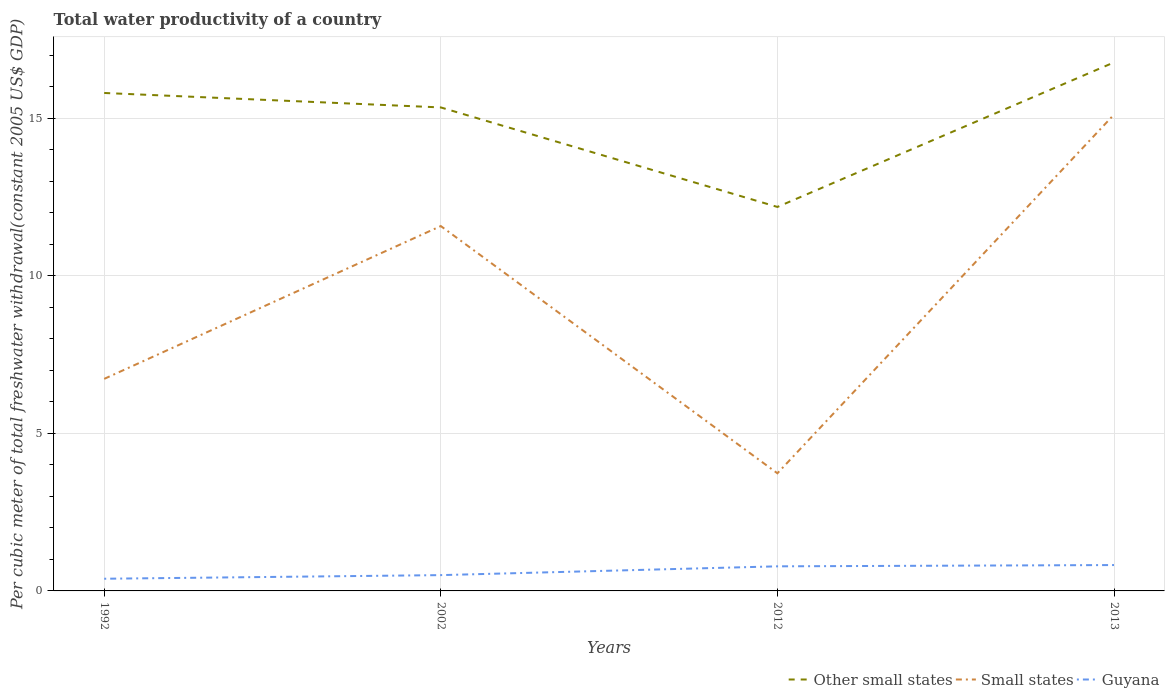Does the line corresponding to Small states intersect with the line corresponding to Guyana?
Keep it short and to the point. No. Across all years, what is the maximum total water productivity in Other small states?
Offer a terse response. 12.19. In which year was the total water productivity in Guyana maximum?
Provide a succinct answer. 1992. What is the total total water productivity in Guyana in the graph?
Ensure brevity in your answer.  -0.43. What is the difference between the highest and the second highest total water productivity in Other small states?
Your answer should be compact. 4.59. Is the total water productivity in Other small states strictly greater than the total water productivity in Guyana over the years?
Give a very brief answer. No. How many years are there in the graph?
Ensure brevity in your answer.  4. Does the graph contain grids?
Your answer should be compact. Yes. How many legend labels are there?
Ensure brevity in your answer.  3. How are the legend labels stacked?
Provide a succinct answer. Horizontal. What is the title of the graph?
Provide a short and direct response. Total water productivity of a country. Does "Macao" appear as one of the legend labels in the graph?
Your answer should be compact. No. What is the label or title of the Y-axis?
Your answer should be compact. Per cubic meter of total freshwater withdrawal(constant 2005 US$ GDP). What is the Per cubic meter of total freshwater withdrawal(constant 2005 US$ GDP) of Other small states in 1992?
Give a very brief answer. 15.81. What is the Per cubic meter of total freshwater withdrawal(constant 2005 US$ GDP) in Small states in 1992?
Ensure brevity in your answer.  6.73. What is the Per cubic meter of total freshwater withdrawal(constant 2005 US$ GDP) in Guyana in 1992?
Offer a terse response. 0.39. What is the Per cubic meter of total freshwater withdrawal(constant 2005 US$ GDP) in Other small states in 2002?
Provide a short and direct response. 15.35. What is the Per cubic meter of total freshwater withdrawal(constant 2005 US$ GDP) in Small states in 2002?
Provide a succinct answer. 11.58. What is the Per cubic meter of total freshwater withdrawal(constant 2005 US$ GDP) of Guyana in 2002?
Make the answer very short. 0.5. What is the Per cubic meter of total freshwater withdrawal(constant 2005 US$ GDP) of Other small states in 2012?
Ensure brevity in your answer.  12.19. What is the Per cubic meter of total freshwater withdrawal(constant 2005 US$ GDP) of Small states in 2012?
Your answer should be compact. 3.73. What is the Per cubic meter of total freshwater withdrawal(constant 2005 US$ GDP) of Guyana in 2012?
Your response must be concise. 0.78. What is the Per cubic meter of total freshwater withdrawal(constant 2005 US$ GDP) of Other small states in 2013?
Make the answer very short. 16.78. What is the Per cubic meter of total freshwater withdrawal(constant 2005 US$ GDP) of Small states in 2013?
Make the answer very short. 15.12. What is the Per cubic meter of total freshwater withdrawal(constant 2005 US$ GDP) in Guyana in 2013?
Keep it short and to the point. 0.82. Across all years, what is the maximum Per cubic meter of total freshwater withdrawal(constant 2005 US$ GDP) in Other small states?
Your answer should be compact. 16.78. Across all years, what is the maximum Per cubic meter of total freshwater withdrawal(constant 2005 US$ GDP) in Small states?
Offer a terse response. 15.12. Across all years, what is the maximum Per cubic meter of total freshwater withdrawal(constant 2005 US$ GDP) of Guyana?
Give a very brief answer. 0.82. Across all years, what is the minimum Per cubic meter of total freshwater withdrawal(constant 2005 US$ GDP) of Other small states?
Offer a terse response. 12.19. Across all years, what is the minimum Per cubic meter of total freshwater withdrawal(constant 2005 US$ GDP) in Small states?
Provide a short and direct response. 3.73. Across all years, what is the minimum Per cubic meter of total freshwater withdrawal(constant 2005 US$ GDP) of Guyana?
Your answer should be compact. 0.39. What is the total Per cubic meter of total freshwater withdrawal(constant 2005 US$ GDP) in Other small states in the graph?
Give a very brief answer. 60.12. What is the total Per cubic meter of total freshwater withdrawal(constant 2005 US$ GDP) in Small states in the graph?
Offer a terse response. 37.17. What is the total Per cubic meter of total freshwater withdrawal(constant 2005 US$ GDP) in Guyana in the graph?
Provide a succinct answer. 2.49. What is the difference between the Per cubic meter of total freshwater withdrawal(constant 2005 US$ GDP) in Other small states in 1992 and that in 2002?
Ensure brevity in your answer.  0.46. What is the difference between the Per cubic meter of total freshwater withdrawal(constant 2005 US$ GDP) in Small states in 1992 and that in 2002?
Your response must be concise. -4.85. What is the difference between the Per cubic meter of total freshwater withdrawal(constant 2005 US$ GDP) of Guyana in 1992 and that in 2002?
Offer a very short reply. -0.12. What is the difference between the Per cubic meter of total freshwater withdrawal(constant 2005 US$ GDP) of Other small states in 1992 and that in 2012?
Offer a very short reply. 3.62. What is the difference between the Per cubic meter of total freshwater withdrawal(constant 2005 US$ GDP) in Small states in 1992 and that in 2012?
Offer a terse response. 3. What is the difference between the Per cubic meter of total freshwater withdrawal(constant 2005 US$ GDP) of Guyana in 1992 and that in 2012?
Offer a terse response. -0.39. What is the difference between the Per cubic meter of total freshwater withdrawal(constant 2005 US$ GDP) in Other small states in 1992 and that in 2013?
Keep it short and to the point. -0.97. What is the difference between the Per cubic meter of total freshwater withdrawal(constant 2005 US$ GDP) of Small states in 1992 and that in 2013?
Offer a very short reply. -8.39. What is the difference between the Per cubic meter of total freshwater withdrawal(constant 2005 US$ GDP) in Guyana in 1992 and that in 2013?
Give a very brief answer. -0.43. What is the difference between the Per cubic meter of total freshwater withdrawal(constant 2005 US$ GDP) of Other small states in 2002 and that in 2012?
Make the answer very short. 3.16. What is the difference between the Per cubic meter of total freshwater withdrawal(constant 2005 US$ GDP) of Small states in 2002 and that in 2012?
Provide a succinct answer. 7.85. What is the difference between the Per cubic meter of total freshwater withdrawal(constant 2005 US$ GDP) of Guyana in 2002 and that in 2012?
Offer a very short reply. -0.28. What is the difference between the Per cubic meter of total freshwater withdrawal(constant 2005 US$ GDP) in Other small states in 2002 and that in 2013?
Your answer should be very brief. -1.43. What is the difference between the Per cubic meter of total freshwater withdrawal(constant 2005 US$ GDP) in Small states in 2002 and that in 2013?
Offer a terse response. -3.54. What is the difference between the Per cubic meter of total freshwater withdrawal(constant 2005 US$ GDP) of Guyana in 2002 and that in 2013?
Give a very brief answer. -0.32. What is the difference between the Per cubic meter of total freshwater withdrawal(constant 2005 US$ GDP) of Other small states in 2012 and that in 2013?
Ensure brevity in your answer.  -4.59. What is the difference between the Per cubic meter of total freshwater withdrawal(constant 2005 US$ GDP) in Small states in 2012 and that in 2013?
Your response must be concise. -11.39. What is the difference between the Per cubic meter of total freshwater withdrawal(constant 2005 US$ GDP) in Guyana in 2012 and that in 2013?
Offer a very short reply. -0.04. What is the difference between the Per cubic meter of total freshwater withdrawal(constant 2005 US$ GDP) of Other small states in 1992 and the Per cubic meter of total freshwater withdrawal(constant 2005 US$ GDP) of Small states in 2002?
Offer a very short reply. 4.22. What is the difference between the Per cubic meter of total freshwater withdrawal(constant 2005 US$ GDP) in Other small states in 1992 and the Per cubic meter of total freshwater withdrawal(constant 2005 US$ GDP) in Guyana in 2002?
Your response must be concise. 15.31. What is the difference between the Per cubic meter of total freshwater withdrawal(constant 2005 US$ GDP) in Small states in 1992 and the Per cubic meter of total freshwater withdrawal(constant 2005 US$ GDP) in Guyana in 2002?
Offer a terse response. 6.23. What is the difference between the Per cubic meter of total freshwater withdrawal(constant 2005 US$ GDP) in Other small states in 1992 and the Per cubic meter of total freshwater withdrawal(constant 2005 US$ GDP) in Small states in 2012?
Make the answer very short. 12.07. What is the difference between the Per cubic meter of total freshwater withdrawal(constant 2005 US$ GDP) of Other small states in 1992 and the Per cubic meter of total freshwater withdrawal(constant 2005 US$ GDP) of Guyana in 2012?
Give a very brief answer. 15.03. What is the difference between the Per cubic meter of total freshwater withdrawal(constant 2005 US$ GDP) in Small states in 1992 and the Per cubic meter of total freshwater withdrawal(constant 2005 US$ GDP) in Guyana in 2012?
Provide a short and direct response. 5.95. What is the difference between the Per cubic meter of total freshwater withdrawal(constant 2005 US$ GDP) of Other small states in 1992 and the Per cubic meter of total freshwater withdrawal(constant 2005 US$ GDP) of Small states in 2013?
Your answer should be compact. 0.69. What is the difference between the Per cubic meter of total freshwater withdrawal(constant 2005 US$ GDP) in Other small states in 1992 and the Per cubic meter of total freshwater withdrawal(constant 2005 US$ GDP) in Guyana in 2013?
Your answer should be very brief. 14.99. What is the difference between the Per cubic meter of total freshwater withdrawal(constant 2005 US$ GDP) of Small states in 1992 and the Per cubic meter of total freshwater withdrawal(constant 2005 US$ GDP) of Guyana in 2013?
Ensure brevity in your answer.  5.91. What is the difference between the Per cubic meter of total freshwater withdrawal(constant 2005 US$ GDP) of Other small states in 2002 and the Per cubic meter of total freshwater withdrawal(constant 2005 US$ GDP) of Small states in 2012?
Your response must be concise. 11.61. What is the difference between the Per cubic meter of total freshwater withdrawal(constant 2005 US$ GDP) in Other small states in 2002 and the Per cubic meter of total freshwater withdrawal(constant 2005 US$ GDP) in Guyana in 2012?
Your response must be concise. 14.57. What is the difference between the Per cubic meter of total freshwater withdrawal(constant 2005 US$ GDP) of Small states in 2002 and the Per cubic meter of total freshwater withdrawal(constant 2005 US$ GDP) of Guyana in 2012?
Offer a terse response. 10.8. What is the difference between the Per cubic meter of total freshwater withdrawal(constant 2005 US$ GDP) in Other small states in 2002 and the Per cubic meter of total freshwater withdrawal(constant 2005 US$ GDP) in Small states in 2013?
Provide a succinct answer. 0.23. What is the difference between the Per cubic meter of total freshwater withdrawal(constant 2005 US$ GDP) in Other small states in 2002 and the Per cubic meter of total freshwater withdrawal(constant 2005 US$ GDP) in Guyana in 2013?
Ensure brevity in your answer.  14.53. What is the difference between the Per cubic meter of total freshwater withdrawal(constant 2005 US$ GDP) of Small states in 2002 and the Per cubic meter of total freshwater withdrawal(constant 2005 US$ GDP) of Guyana in 2013?
Your answer should be very brief. 10.76. What is the difference between the Per cubic meter of total freshwater withdrawal(constant 2005 US$ GDP) of Other small states in 2012 and the Per cubic meter of total freshwater withdrawal(constant 2005 US$ GDP) of Small states in 2013?
Provide a short and direct response. -2.93. What is the difference between the Per cubic meter of total freshwater withdrawal(constant 2005 US$ GDP) of Other small states in 2012 and the Per cubic meter of total freshwater withdrawal(constant 2005 US$ GDP) of Guyana in 2013?
Your response must be concise. 11.37. What is the difference between the Per cubic meter of total freshwater withdrawal(constant 2005 US$ GDP) of Small states in 2012 and the Per cubic meter of total freshwater withdrawal(constant 2005 US$ GDP) of Guyana in 2013?
Your response must be concise. 2.91. What is the average Per cubic meter of total freshwater withdrawal(constant 2005 US$ GDP) in Other small states per year?
Provide a short and direct response. 15.03. What is the average Per cubic meter of total freshwater withdrawal(constant 2005 US$ GDP) in Small states per year?
Provide a short and direct response. 9.29. What is the average Per cubic meter of total freshwater withdrawal(constant 2005 US$ GDP) of Guyana per year?
Offer a terse response. 0.62. In the year 1992, what is the difference between the Per cubic meter of total freshwater withdrawal(constant 2005 US$ GDP) in Other small states and Per cubic meter of total freshwater withdrawal(constant 2005 US$ GDP) in Small states?
Keep it short and to the point. 9.08. In the year 1992, what is the difference between the Per cubic meter of total freshwater withdrawal(constant 2005 US$ GDP) in Other small states and Per cubic meter of total freshwater withdrawal(constant 2005 US$ GDP) in Guyana?
Your response must be concise. 15.42. In the year 1992, what is the difference between the Per cubic meter of total freshwater withdrawal(constant 2005 US$ GDP) in Small states and Per cubic meter of total freshwater withdrawal(constant 2005 US$ GDP) in Guyana?
Offer a terse response. 6.34. In the year 2002, what is the difference between the Per cubic meter of total freshwater withdrawal(constant 2005 US$ GDP) in Other small states and Per cubic meter of total freshwater withdrawal(constant 2005 US$ GDP) in Small states?
Your answer should be compact. 3.77. In the year 2002, what is the difference between the Per cubic meter of total freshwater withdrawal(constant 2005 US$ GDP) in Other small states and Per cubic meter of total freshwater withdrawal(constant 2005 US$ GDP) in Guyana?
Offer a very short reply. 14.85. In the year 2002, what is the difference between the Per cubic meter of total freshwater withdrawal(constant 2005 US$ GDP) of Small states and Per cubic meter of total freshwater withdrawal(constant 2005 US$ GDP) of Guyana?
Ensure brevity in your answer.  11.08. In the year 2012, what is the difference between the Per cubic meter of total freshwater withdrawal(constant 2005 US$ GDP) in Other small states and Per cubic meter of total freshwater withdrawal(constant 2005 US$ GDP) in Small states?
Give a very brief answer. 8.45. In the year 2012, what is the difference between the Per cubic meter of total freshwater withdrawal(constant 2005 US$ GDP) of Other small states and Per cubic meter of total freshwater withdrawal(constant 2005 US$ GDP) of Guyana?
Give a very brief answer. 11.41. In the year 2012, what is the difference between the Per cubic meter of total freshwater withdrawal(constant 2005 US$ GDP) in Small states and Per cubic meter of total freshwater withdrawal(constant 2005 US$ GDP) in Guyana?
Your answer should be compact. 2.95. In the year 2013, what is the difference between the Per cubic meter of total freshwater withdrawal(constant 2005 US$ GDP) of Other small states and Per cubic meter of total freshwater withdrawal(constant 2005 US$ GDP) of Small states?
Your answer should be compact. 1.66. In the year 2013, what is the difference between the Per cubic meter of total freshwater withdrawal(constant 2005 US$ GDP) of Other small states and Per cubic meter of total freshwater withdrawal(constant 2005 US$ GDP) of Guyana?
Give a very brief answer. 15.96. In the year 2013, what is the difference between the Per cubic meter of total freshwater withdrawal(constant 2005 US$ GDP) in Small states and Per cubic meter of total freshwater withdrawal(constant 2005 US$ GDP) in Guyana?
Your response must be concise. 14.3. What is the ratio of the Per cubic meter of total freshwater withdrawal(constant 2005 US$ GDP) of Other small states in 1992 to that in 2002?
Provide a short and direct response. 1.03. What is the ratio of the Per cubic meter of total freshwater withdrawal(constant 2005 US$ GDP) of Small states in 1992 to that in 2002?
Keep it short and to the point. 0.58. What is the ratio of the Per cubic meter of total freshwater withdrawal(constant 2005 US$ GDP) of Guyana in 1992 to that in 2002?
Your answer should be very brief. 0.77. What is the ratio of the Per cubic meter of total freshwater withdrawal(constant 2005 US$ GDP) of Other small states in 1992 to that in 2012?
Your response must be concise. 1.3. What is the ratio of the Per cubic meter of total freshwater withdrawal(constant 2005 US$ GDP) of Small states in 1992 to that in 2012?
Keep it short and to the point. 1.8. What is the ratio of the Per cubic meter of total freshwater withdrawal(constant 2005 US$ GDP) in Guyana in 1992 to that in 2012?
Your response must be concise. 0.5. What is the ratio of the Per cubic meter of total freshwater withdrawal(constant 2005 US$ GDP) in Other small states in 1992 to that in 2013?
Keep it short and to the point. 0.94. What is the ratio of the Per cubic meter of total freshwater withdrawal(constant 2005 US$ GDP) in Small states in 1992 to that in 2013?
Make the answer very short. 0.45. What is the ratio of the Per cubic meter of total freshwater withdrawal(constant 2005 US$ GDP) in Guyana in 1992 to that in 2013?
Your answer should be compact. 0.47. What is the ratio of the Per cubic meter of total freshwater withdrawal(constant 2005 US$ GDP) in Other small states in 2002 to that in 2012?
Your response must be concise. 1.26. What is the ratio of the Per cubic meter of total freshwater withdrawal(constant 2005 US$ GDP) in Small states in 2002 to that in 2012?
Provide a succinct answer. 3.1. What is the ratio of the Per cubic meter of total freshwater withdrawal(constant 2005 US$ GDP) in Guyana in 2002 to that in 2012?
Make the answer very short. 0.64. What is the ratio of the Per cubic meter of total freshwater withdrawal(constant 2005 US$ GDP) in Other small states in 2002 to that in 2013?
Give a very brief answer. 0.91. What is the ratio of the Per cubic meter of total freshwater withdrawal(constant 2005 US$ GDP) of Small states in 2002 to that in 2013?
Provide a short and direct response. 0.77. What is the ratio of the Per cubic meter of total freshwater withdrawal(constant 2005 US$ GDP) of Guyana in 2002 to that in 2013?
Give a very brief answer. 0.61. What is the ratio of the Per cubic meter of total freshwater withdrawal(constant 2005 US$ GDP) in Other small states in 2012 to that in 2013?
Provide a succinct answer. 0.73. What is the ratio of the Per cubic meter of total freshwater withdrawal(constant 2005 US$ GDP) in Small states in 2012 to that in 2013?
Keep it short and to the point. 0.25. What is the ratio of the Per cubic meter of total freshwater withdrawal(constant 2005 US$ GDP) of Guyana in 2012 to that in 2013?
Provide a short and direct response. 0.95. What is the difference between the highest and the second highest Per cubic meter of total freshwater withdrawal(constant 2005 US$ GDP) in Other small states?
Ensure brevity in your answer.  0.97. What is the difference between the highest and the second highest Per cubic meter of total freshwater withdrawal(constant 2005 US$ GDP) of Small states?
Provide a short and direct response. 3.54. What is the difference between the highest and the second highest Per cubic meter of total freshwater withdrawal(constant 2005 US$ GDP) of Guyana?
Make the answer very short. 0.04. What is the difference between the highest and the lowest Per cubic meter of total freshwater withdrawal(constant 2005 US$ GDP) of Other small states?
Give a very brief answer. 4.59. What is the difference between the highest and the lowest Per cubic meter of total freshwater withdrawal(constant 2005 US$ GDP) in Small states?
Your response must be concise. 11.39. What is the difference between the highest and the lowest Per cubic meter of total freshwater withdrawal(constant 2005 US$ GDP) in Guyana?
Offer a terse response. 0.43. 